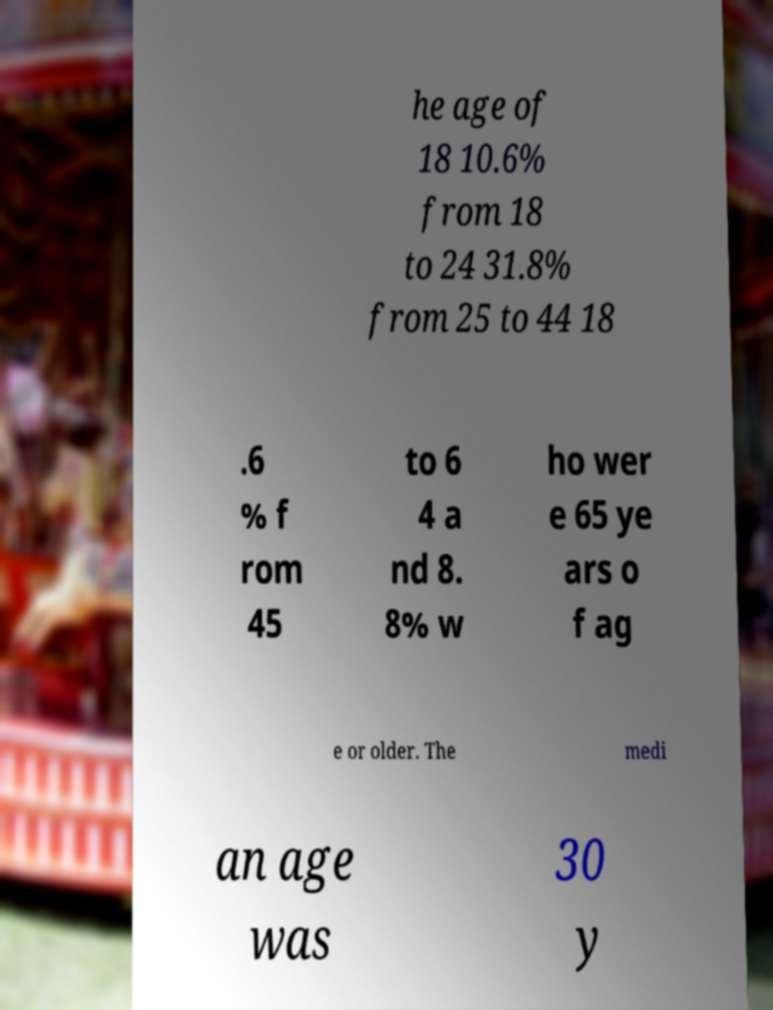What messages or text are displayed in this image? I need them in a readable, typed format. he age of 18 10.6% from 18 to 24 31.8% from 25 to 44 18 .6 % f rom 45 to 6 4 a nd 8. 8% w ho wer e 65 ye ars o f ag e or older. The medi an age was 30 y 